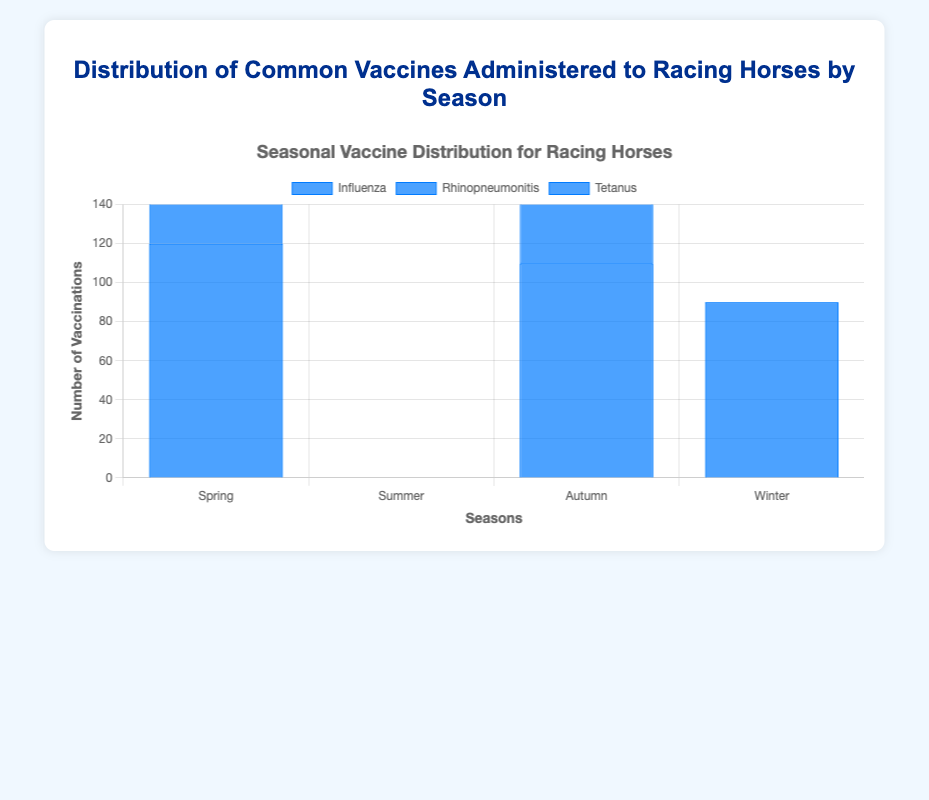Which season has the highest number of Influenza vaccinations? Look at the height of the bars representing Influenza vaccinations for each season. The tallest bar indicates the highest count.
Answer: Spring How many more Tetanus vaccinations are administered in Spring compared to Summer? Compare the Tetanus bar height from Spring and Summer. Since Summer does not have a Tetanus bar, it's 80 (from Spring) - 0 (from Summer).
Answer: 80 Which vaccine has the highest count in Autumn? Identify the tallest bar in Autumn.
Answer: Influenza What's the total number of West Nile Virus vaccinations across all seasons? Sum the values for West Nile Virus from each season. Only Summer has 100 West Nile Virus vaccinations.
Answer: 100 Is the number of Equine Encephalomyelitis vaccinations in Summer greater than the number of Botulism vaccinations in Autumn? Compare the height of the Equine Encephalomyelitis bar in Summer to the Botulism bar in Autumn. Equine Encephalomyelitis is 90, and Botulism is 70. 90 > 70.
Answer: Yes What's the average number of Rhinopneumonitis vaccinations administered across all seasons? Add the Rhinopneumonitis counts for all seasons and divide by the number of seasons: (95 in Spring + 85 in Autumn + 90 in Winter) / 3.
Answer: 90 Which season has the lowest total number of vaccinations administered? Sum the vaccination counts for each season and compare.
Answer: Winter Are there any vaccines administered only in one season? If so, which ones? Identify bars that appear only once on the graph.
Answer: West Nile Virus, Potomac Horse Fever, Botulism, Equine Viral Arteritis, Rabies Do any vaccines have the same number of administrations in different seasons? Check for equal bar heights across different seasons for the same vaccine.
Answer: No What's the difference between the number of Influenza vaccinations in Spring and Autumn? Subtract the number of Influenza vaccinations in Autumn from those in Spring: 120 (Spring) - 110 (Autumn).
Answer: 10 